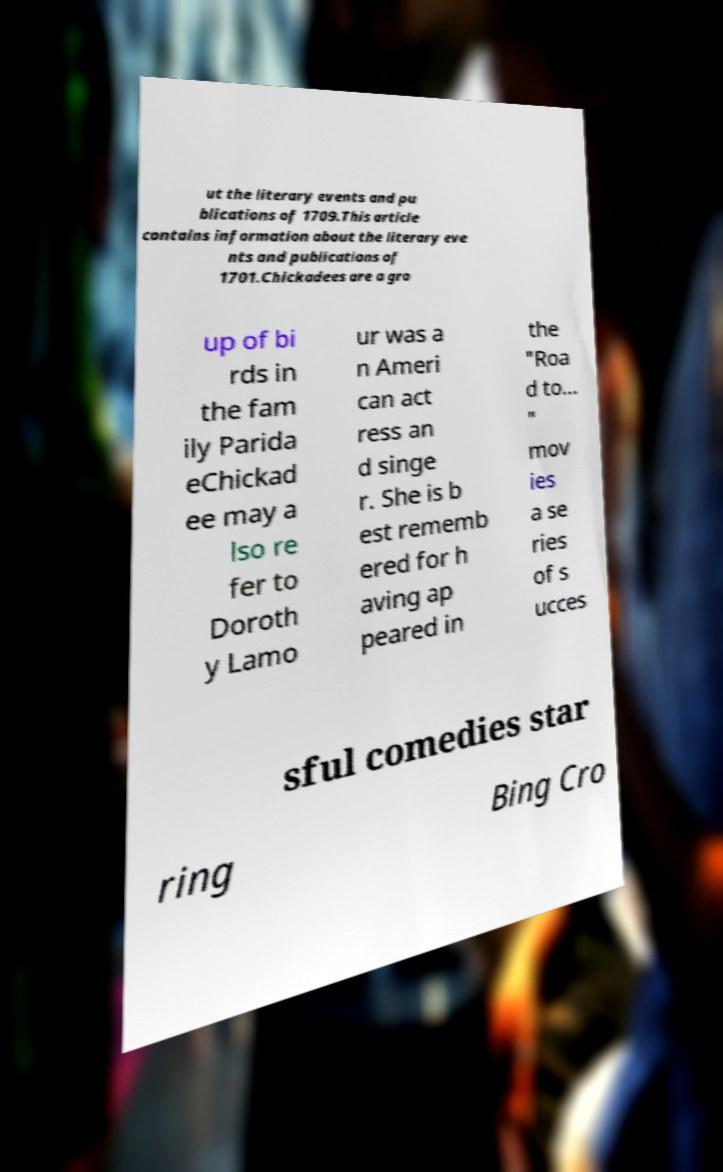Could you assist in decoding the text presented in this image and type it out clearly? ut the literary events and pu blications of 1709.This article contains information about the literary eve nts and publications of 1701.Chickadees are a gro up of bi rds in the fam ily Parida eChickad ee may a lso re fer to Doroth y Lamo ur was a n Ameri can act ress an d singe r. She is b est rememb ered for h aving ap peared in the "Roa d to... " mov ies a se ries of s ucces sful comedies star ring Bing Cro 